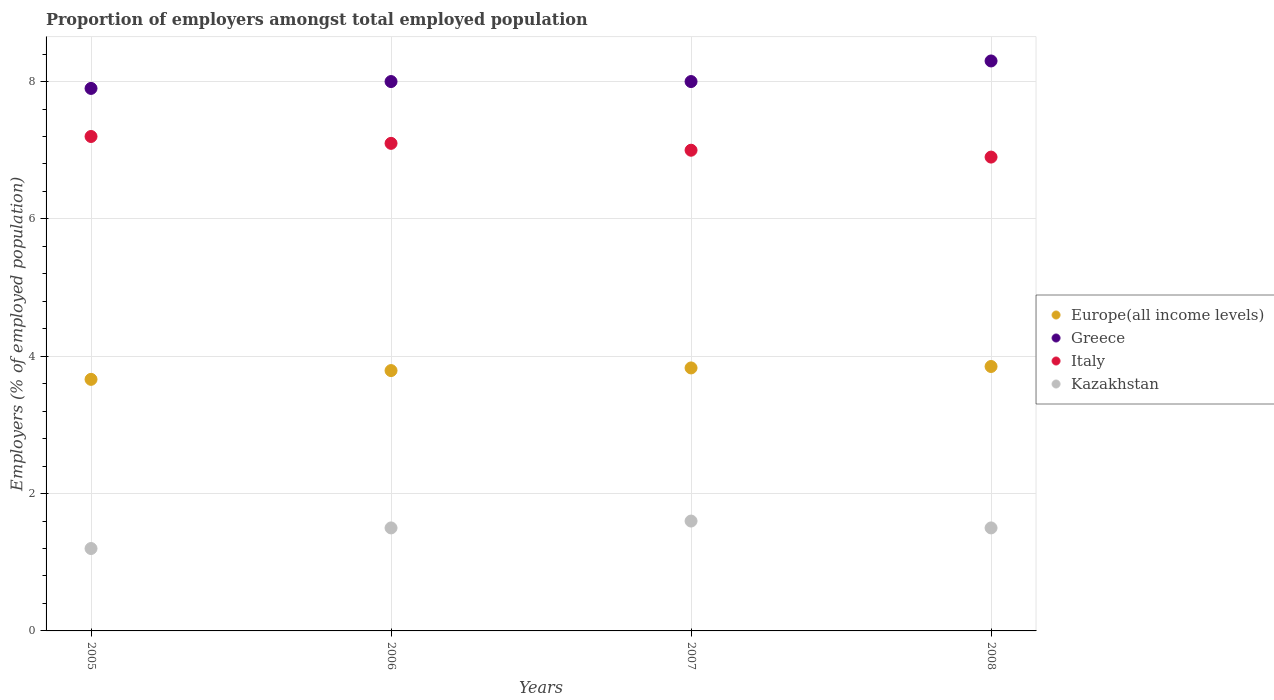How many different coloured dotlines are there?
Make the answer very short. 4. What is the proportion of employers in Kazakhstan in 2008?
Give a very brief answer. 1.5. Across all years, what is the maximum proportion of employers in Italy?
Offer a terse response. 7.2. Across all years, what is the minimum proportion of employers in Kazakhstan?
Ensure brevity in your answer.  1.2. In which year was the proportion of employers in Kazakhstan maximum?
Make the answer very short. 2007. In which year was the proportion of employers in Europe(all income levels) minimum?
Offer a terse response. 2005. What is the total proportion of employers in Italy in the graph?
Provide a short and direct response. 28.2. What is the difference between the proportion of employers in Kazakhstan in 2005 and that in 2008?
Your response must be concise. -0.3. What is the difference between the proportion of employers in Italy in 2006 and the proportion of employers in Europe(all income levels) in 2008?
Provide a short and direct response. 3.25. What is the average proportion of employers in Kazakhstan per year?
Your response must be concise. 1.45. In the year 2007, what is the difference between the proportion of employers in Kazakhstan and proportion of employers in Italy?
Offer a terse response. -5.4. In how many years, is the proportion of employers in Europe(all income levels) greater than 6.4 %?
Keep it short and to the point. 0. What is the ratio of the proportion of employers in Europe(all income levels) in 2006 to that in 2008?
Your answer should be compact. 0.98. Is the proportion of employers in Italy in 2006 less than that in 2008?
Give a very brief answer. No. Is the difference between the proportion of employers in Kazakhstan in 2005 and 2008 greater than the difference between the proportion of employers in Italy in 2005 and 2008?
Offer a very short reply. No. What is the difference between the highest and the second highest proportion of employers in Europe(all income levels)?
Ensure brevity in your answer.  0.02. What is the difference between the highest and the lowest proportion of employers in Europe(all income levels)?
Offer a very short reply. 0.19. In how many years, is the proportion of employers in Kazakhstan greater than the average proportion of employers in Kazakhstan taken over all years?
Your response must be concise. 3. Is it the case that in every year, the sum of the proportion of employers in Kazakhstan and proportion of employers in Europe(all income levels)  is greater than the sum of proportion of employers in Greece and proportion of employers in Italy?
Give a very brief answer. No. Is the proportion of employers in Italy strictly greater than the proportion of employers in Kazakhstan over the years?
Give a very brief answer. Yes. Is the proportion of employers in Europe(all income levels) strictly less than the proportion of employers in Italy over the years?
Your answer should be compact. Yes. How many dotlines are there?
Offer a very short reply. 4. How many years are there in the graph?
Your answer should be very brief. 4. Are the values on the major ticks of Y-axis written in scientific E-notation?
Provide a succinct answer. No. Where does the legend appear in the graph?
Offer a terse response. Center right. How many legend labels are there?
Ensure brevity in your answer.  4. What is the title of the graph?
Keep it short and to the point. Proportion of employers amongst total employed population. Does "Guam" appear as one of the legend labels in the graph?
Provide a short and direct response. No. What is the label or title of the X-axis?
Provide a short and direct response. Years. What is the label or title of the Y-axis?
Give a very brief answer. Employers (% of employed population). What is the Employers (% of employed population) of Europe(all income levels) in 2005?
Your answer should be compact. 3.66. What is the Employers (% of employed population) in Greece in 2005?
Give a very brief answer. 7.9. What is the Employers (% of employed population) of Italy in 2005?
Keep it short and to the point. 7.2. What is the Employers (% of employed population) of Kazakhstan in 2005?
Offer a very short reply. 1.2. What is the Employers (% of employed population) in Europe(all income levels) in 2006?
Make the answer very short. 3.79. What is the Employers (% of employed population) in Italy in 2006?
Offer a terse response. 7.1. What is the Employers (% of employed population) in Kazakhstan in 2006?
Ensure brevity in your answer.  1.5. What is the Employers (% of employed population) in Europe(all income levels) in 2007?
Give a very brief answer. 3.83. What is the Employers (% of employed population) of Greece in 2007?
Give a very brief answer. 8. What is the Employers (% of employed population) in Italy in 2007?
Give a very brief answer. 7. What is the Employers (% of employed population) of Kazakhstan in 2007?
Provide a succinct answer. 1.6. What is the Employers (% of employed population) in Europe(all income levels) in 2008?
Keep it short and to the point. 3.85. What is the Employers (% of employed population) in Greece in 2008?
Your response must be concise. 8.3. What is the Employers (% of employed population) in Italy in 2008?
Your answer should be compact. 6.9. Across all years, what is the maximum Employers (% of employed population) of Europe(all income levels)?
Offer a very short reply. 3.85. Across all years, what is the maximum Employers (% of employed population) in Greece?
Provide a succinct answer. 8.3. Across all years, what is the maximum Employers (% of employed population) of Italy?
Provide a succinct answer. 7.2. Across all years, what is the maximum Employers (% of employed population) in Kazakhstan?
Keep it short and to the point. 1.6. Across all years, what is the minimum Employers (% of employed population) in Europe(all income levels)?
Your answer should be very brief. 3.66. Across all years, what is the minimum Employers (% of employed population) of Greece?
Give a very brief answer. 7.9. Across all years, what is the minimum Employers (% of employed population) of Italy?
Make the answer very short. 6.9. Across all years, what is the minimum Employers (% of employed population) in Kazakhstan?
Offer a very short reply. 1.2. What is the total Employers (% of employed population) in Europe(all income levels) in the graph?
Your answer should be compact. 15.13. What is the total Employers (% of employed population) of Greece in the graph?
Provide a succinct answer. 32.2. What is the total Employers (% of employed population) of Italy in the graph?
Give a very brief answer. 28.2. What is the total Employers (% of employed population) of Kazakhstan in the graph?
Ensure brevity in your answer.  5.8. What is the difference between the Employers (% of employed population) in Europe(all income levels) in 2005 and that in 2006?
Give a very brief answer. -0.13. What is the difference between the Employers (% of employed population) in Italy in 2005 and that in 2006?
Keep it short and to the point. 0.1. What is the difference between the Employers (% of employed population) in Europe(all income levels) in 2005 and that in 2007?
Keep it short and to the point. -0.17. What is the difference between the Employers (% of employed population) of Kazakhstan in 2005 and that in 2007?
Offer a terse response. -0.4. What is the difference between the Employers (% of employed population) of Europe(all income levels) in 2005 and that in 2008?
Make the answer very short. -0.19. What is the difference between the Employers (% of employed population) in Italy in 2005 and that in 2008?
Offer a very short reply. 0.3. What is the difference between the Employers (% of employed population) in Kazakhstan in 2005 and that in 2008?
Offer a very short reply. -0.3. What is the difference between the Employers (% of employed population) in Europe(all income levels) in 2006 and that in 2007?
Make the answer very short. -0.04. What is the difference between the Employers (% of employed population) in Greece in 2006 and that in 2007?
Provide a succinct answer. 0. What is the difference between the Employers (% of employed population) of Italy in 2006 and that in 2007?
Keep it short and to the point. 0.1. What is the difference between the Employers (% of employed population) in Kazakhstan in 2006 and that in 2007?
Your answer should be very brief. -0.1. What is the difference between the Employers (% of employed population) of Europe(all income levels) in 2006 and that in 2008?
Your answer should be very brief. -0.06. What is the difference between the Employers (% of employed population) of Greece in 2006 and that in 2008?
Make the answer very short. -0.3. What is the difference between the Employers (% of employed population) in Italy in 2006 and that in 2008?
Provide a succinct answer. 0.2. What is the difference between the Employers (% of employed population) in Kazakhstan in 2006 and that in 2008?
Keep it short and to the point. 0. What is the difference between the Employers (% of employed population) in Europe(all income levels) in 2007 and that in 2008?
Your answer should be compact. -0.02. What is the difference between the Employers (% of employed population) of Italy in 2007 and that in 2008?
Your answer should be compact. 0.1. What is the difference between the Employers (% of employed population) of Kazakhstan in 2007 and that in 2008?
Keep it short and to the point. 0.1. What is the difference between the Employers (% of employed population) of Europe(all income levels) in 2005 and the Employers (% of employed population) of Greece in 2006?
Your answer should be very brief. -4.34. What is the difference between the Employers (% of employed population) in Europe(all income levels) in 2005 and the Employers (% of employed population) in Italy in 2006?
Your response must be concise. -3.44. What is the difference between the Employers (% of employed population) of Europe(all income levels) in 2005 and the Employers (% of employed population) of Kazakhstan in 2006?
Offer a terse response. 2.16. What is the difference between the Employers (% of employed population) of Greece in 2005 and the Employers (% of employed population) of Italy in 2006?
Your response must be concise. 0.8. What is the difference between the Employers (% of employed population) in Greece in 2005 and the Employers (% of employed population) in Kazakhstan in 2006?
Make the answer very short. 6.4. What is the difference between the Employers (% of employed population) in Europe(all income levels) in 2005 and the Employers (% of employed population) in Greece in 2007?
Offer a very short reply. -4.34. What is the difference between the Employers (% of employed population) of Europe(all income levels) in 2005 and the Employers (% of employed population) of Italy in 2007?
Offer a terse response. -3.34. What is the difference between the Employers (% of employed population) in Europe(all income levels) in 2005 and the Employers (% of employed population) in Kazakhstan in 2007?
Your answer should be compact. 2.06. What is the difference between the Employers (% of employed population) of Greece in 2005 and the Employers (% of employed population) of Kazakhstan in 2007?
Provide a succinct answer. 6.3. What is the difference between the Employers (% of employed population) of Europe(all income levels) in 2005 and the Employers (% of employed population) of Greece in 2008?
Ensure brevity in your answer.  -4.64. What is the difference between the Employers (% of employed population) in Europe(all income levels) in 2005 and the Employers (% of employed population) in Italy in 2008?
Your answer should be compact. -3.24. What is the difference between the Employers (% of employed population) in Europe(all income levels) in 2005 and the Employers (% of employed population) in Kazakhstan in 2008?
Ensure brevity in your answer.  2.16. What is the difference between the Employers (% of employed population) of Greece in 2005 and the Employers (% of employed population) of Italy in 2008?
Ensure brevity in your answer.  1. What is the difference between the Employers (% of employed population) of Italy in 2005 and the Employers (% of employed population) of Kazakhstan in 2008?
Provide a short and direct response. 5.7. What is the difference between the Employers (% of employed population) of Europe(all income levels) in 2006 and the Employers (% of employed population) of Greece in 2007?
Give a very brief answer. -4.21. What is the difference between the Employers (% of employed population) in Europe(all income levels) in 2006 and the Employers (% of employed population) in Italy in 2007?
Offer a very short reply. -3.21. What is the difference between the Employers (% of employed population) of Europe(all income levels) in 2006 and the Employers (% of employed population) of Kazakhstan in 2007?
Provide a short and direct response. 2.19. What is the difference between the Employers (% of employed population) of Greece in 2006 and the Employers (% of employed population) of Kazakhstan in 2007?
Make the answer very short. 6.4. What is the difference between the Employers (% of employed population) in Italy in 2006 and the Employers (% of employed population) in Kazakhstan in 2007?
Give a very brief answer. 5.5. What is the difference between the Employers (% of employed population) of Europe(all income levels) in 2006 and the Employers (% of employed population) of Greece in 2008?
Your answer should be very brief. -4.51. What is the difference between the Employers (% of employed population) in Europe(all income levels) in 2006 and the Employers (% of employed population) in Italy in 2008?
Keep it short and to the point. -3.11. What is the difference between the Employers (% of employed population) in Europe(all income levels) in 2006 and the Employers (% of employed population) in Kazakhstan in 2008?
Make the answer very short. 2.29. What is the difference between the Employers (% of employed population) of Greece in 2006 and the Employers (% of employed population) of Italy in 2008?
Provide a short and direct response. 1.1. What is the difference between the Employers (% of employed population) in Italy in 2006 and the Employers (% of employed population) in Kazakhstan in 2008?
Offer a very short reply. 5.6. What is the difference between the Employers (% of employed population) in Europe(all income levels) in 2007 and the Employers (% of employed population) in Greece in 2008?
Keep it short and to the point. -4.47. What is the difference between the Employers (% of employed population) of Europe(all income levels) in 2007 and the Employers (% of employed population) of Italy in 2008?
Provide a succinct answer. -3.07. What is the difference between the Employers (% of employed population) in Europe(all income levels) in 2007 and the Employers (% of employed population) in Kazakhstan in 2008?
Provide a short and direct response. 2.33. What is the difference between the Employers (% of employed population) in Greece in 2007 and the Employers (% of employed population) in Kazakhstan in 2008?
Your answer should be very brief. 6.5. What is the difference between the Employers (% of employed population) in Italy in 2007 and the Employers (% of employed population) in Kazakhstan in 2008?
Provide a short and direct response. 5.5. What is the average Employers (% of employed population) of Europe(all income levels) per year?
Provide a short and direct response. 3.78. What is the average Employers (% of employed population) of Greece per year?
Make the answer very short. 8.05. What is the average Employers (% of employed population) in Italy per year?
Ensure brevity in your answer.  7.05. What is the average Employers (% of employed population) of Kazakhstan per year?
Give a very brief answer. 1.45. In the year 2005, what is the difference between the Employers (% of employed population) in Europe(all income levels) and Employers (% of employed population) in Greece?
Give a very brief answer. -4.24. In the year 2005, what is the difference between the Employers (% of employed population) of Europe(all income levels) and Employers (% of employed population) of Italy?
Keep it short and to the point. -3.54. In the year 2005, what is the difference between the Employers (% of employed population) in Europe(all income levels) and Employers (% of employed population) in Kazakhstan?
Ensure brevity in your answer.  2.46. In the year 2005, what is the difference between the Employers (% of employed population) of Italy and Employers (% of employed population) of Kazakhstan?
Give a very brief answer. 6. In the year 2006, what is the difference between the Employers (% of employed population) of Europe(all income levels) and Employers (% of employed population) of Greece?
Offer a terse response. -4.21. In the year 2006, what is the difference between the Employers (% of employed population) of Europe(all income levels) and Employers (% of employed population) of Italy?
Provide a succinct answer. -3.31. In the year 2006, what is the difference between the Employers (% of employed population) in Europe(all income levels) and Employers (% of employed population) in Kazakhstan?
Provide a succinct answer. 2.29. In the year 2007, what is the difference between the Employers (% of employed population) of Europe(all income levels) and Employers (% of employed population) of Greece?
Give a very brief answer. -4.17. In the year 2007, what is the difference between the Employers (% of employed population) of Europe(all income levels) and Employers (% of employed population) of Italy?
Ensure brevity in your answer.  -3.17. In the year 2007, what is the difference between the Employers (% of employed population) of Europe(all income levels) and Employers (% of employed population) of Kazakhstan?
Ensure brevity in your answer.  2.23. In the year 2008, what is the difference between the Employers (% of employed population) in Europe(all income levels) and Employers (% of employed population) in Greece?
Your answer should be compact. -4.45. In the year 2008, what is the difference between the Employers (% of employed population) in Europe(all income levels) and Employers (% of employed population) in Italy?
Your answer should be very brief. -3.05. In the year 2008, what is the difference between the Employers (% of employed population) in Europe(all income levels) and Employers (% of employed population) in Kazakhstan?
Keep it short and to the point. 2.35. In the year 2008, what is the difference between the Employers (% of employed population) of Greece and Employers (% of employed population) of Italy?
Offer a very short reply. 1.4. In the year 2008, what is the difference between the Employers (% of employed population) of Greece and Employers (% of employed population) of Kazakhstan?
Provide a succinct answer. 6.8. What is the ratio of the Employers (% of employed population) of Europe(all income levels) in 2005 to that in 2006?
Offer a very short reply. 0.97. What is the ratio of the Employers (% of employed population) in Greece in 2005 to that in 2006?
Keep it short and to the point. 0.99. What is the ratio of the Employers (% of employed population) in Italy in 2005 to that in 2006?
Your answer should be very brief. 1.01. What is the ratio of the Employers (% of employed population) of Kazakhstan in 2005 to that in 2006?
Ensure brevity in your answer.  0.8. What is the ratio of the Employers (% of employed population) in Europe(all income levels) in 2005 to that in 2007?
Offer a very short reply. 0.96. What is the ratio of the Employers (% of employed population) in Greece in 2005 to that in 2007?
Offer a very short reply. 0.99. What is the ratio of the Employers (% of employed population) in Italy in 2005 to that in 2007?
Provide a succinct answer. 1.03. What is the ratio of the Employers (% of employed population) of Europe(all income levels) in 2005 to that in 2008?
Your response must be concise. 0.95. What is the ratio of the Employers (% of employed population) in Greece in 2005 to that in 2008?
Your answer should be compact. 0.95. What is the ratio of the Employers (% of employed population) in Italy in 2005 to that in 2008?
Give a very brief answer. 1.04. What is the ratio of the Employers (% of employed population) in Italy in 2006 to that in 2007?
Your response must be concise. 1.01. What is the ratio of the Employers (% of employed population) in Europe(all income levels) in 2006 to that in 2008?
Your answer should be very brief. 0.98. What is the ratio of the Employers (% of employed population) of Greece in 2006 to that in 2008?
Ensure brevity in your answer.  0.96. What is the ratio of the Employers (% of employed population) in Italy in 2006 to that in 2008?
Provide a short and direct response. 1.03. What is the ratio of the Employers (% of employed population) of Kazakhstan in 2006 to that in 2008?
Provide a short and direct response. 1. What is the ratio of the Employers (% of employed population) in Greece in 2007 to that in 2008?
Provide a succinct answer. 0.96. What is the ratio of the Employers (% of employed population) in Italy in 2007 to that in 2008?
Provide a short and direct response. 1.01. What is the ratio of the Employers (% of employed population) of Kazakhstan in 2007 to that in 2008?
Make the answer very short. 1.07. What is the difference between the highest and the second highest Employers (% of employed population) of Europe(all income levels)?
Provide a succinct answer. 0.02. What is the difference between the highest and the second highest Employers (% of employed population) in Kazakhstan?
Provide a short and direct response. 0.1. What is the difference between the highest and the lowest Employers (% of employed population) of Europe(all income levels)?
Provide a succinct answer. 0.19. What is the difference between the highest and the lowest Employers (% of employed population) of Greece?
Your answer should be compact. 0.4. What is the difference between the highest and the lowest Employers (% of employed population) of Italy?
Your answer should be very brief. 0.3. What is the difference between the highest and the lowest Employers (% of employed population) in Kazakhstan?
Provide a succinct answer. 0.4. 